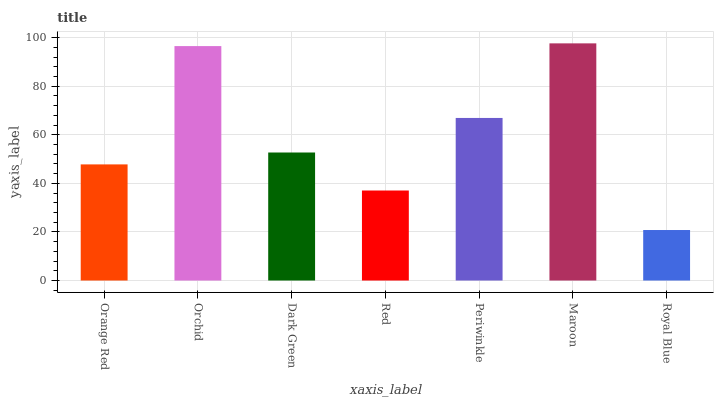Is Royal Blue the minimum?
Answer yes or no. Yes. Is Maroon the maximum?
Answer yes or no. Yes. Is Orchid the minimum?
Answer yes or no. No. Is Orchid the maximum?
Answer yes or no. No. Is Orchid greater than Orange Red?
Answer yes or no. Yes. Is Orange Red less than Orchid?
Answer yes or no. Yes. Is Orange Red greater than Orchid?
Answer yes or no. No. Is Orchid less than Orange Red?
Answer yes or no. No. Is Dark Green the high median?
Answer yes or no. Yes. Is Dark Green the low median?
Answer yes or no. Yes. Is Red the high median?
Answer yes or no. No. Is Orange Red the low median?
Answer yes or no. No. 